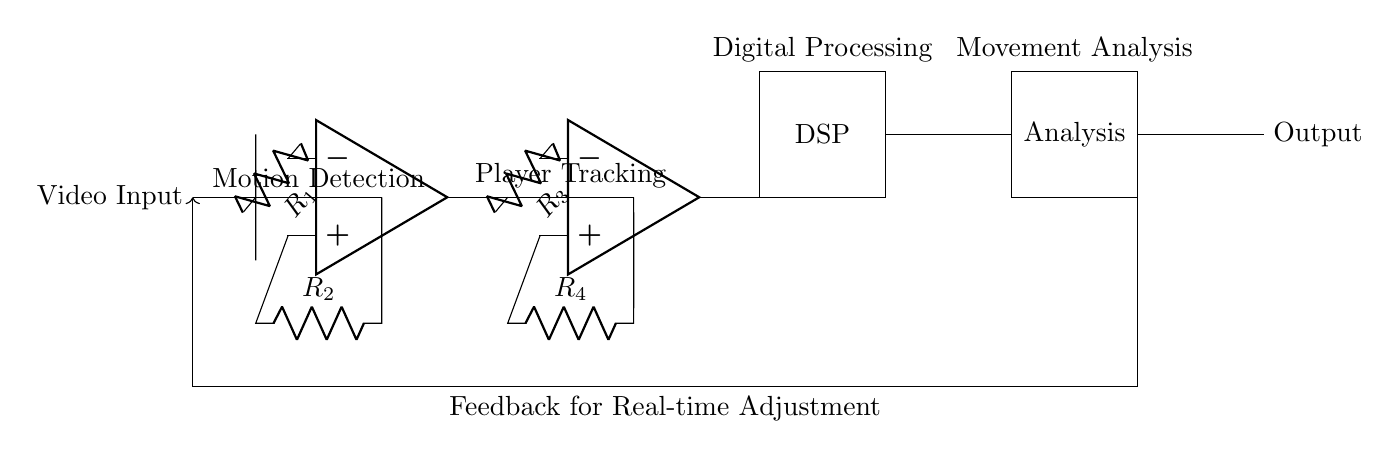What is the function of the first operational amplifier? The first operational amplifier's function is motion detection, which is indicated by the label directly above the component in the circuit.
Answer: motion detection How many resistors are present in the circuit? By counting the resistors labeled in the circuit diagram, we see there are four distinct resistors (R1, R2, R3, and R4).
Answer: four What is the output of the digital signal processing block? The output of the digital signal processing block is connected to the movement analysis block, and the label indicates that this is where processed signals are sent for analysis.
Answer: movement analysis What type of circuit is this? The circuit combines analog processing with digital signal processing for real-time analysis, making it a hybrid signal processing circuit.
Answer: hybrid signal processing circuit What does the feedback loop provide for in this circuit? The feedback loop allows for real-time adjustments to be made based on the analysis results, indicating an adaptive feedback mechanism for performance improvement.
Answer: feedback for real-time adjustment What are the key components used for player tracking? The key components used for player tracking are the second operational amplifier and its associated resistors (R3 and R4).
Answer: operational amplifier and resistors Where does the video input originate from? The video input originates from the left side of the circuit diagram, as indicated by the label directly connected to the starting node of the circuit.
Answer: left side 